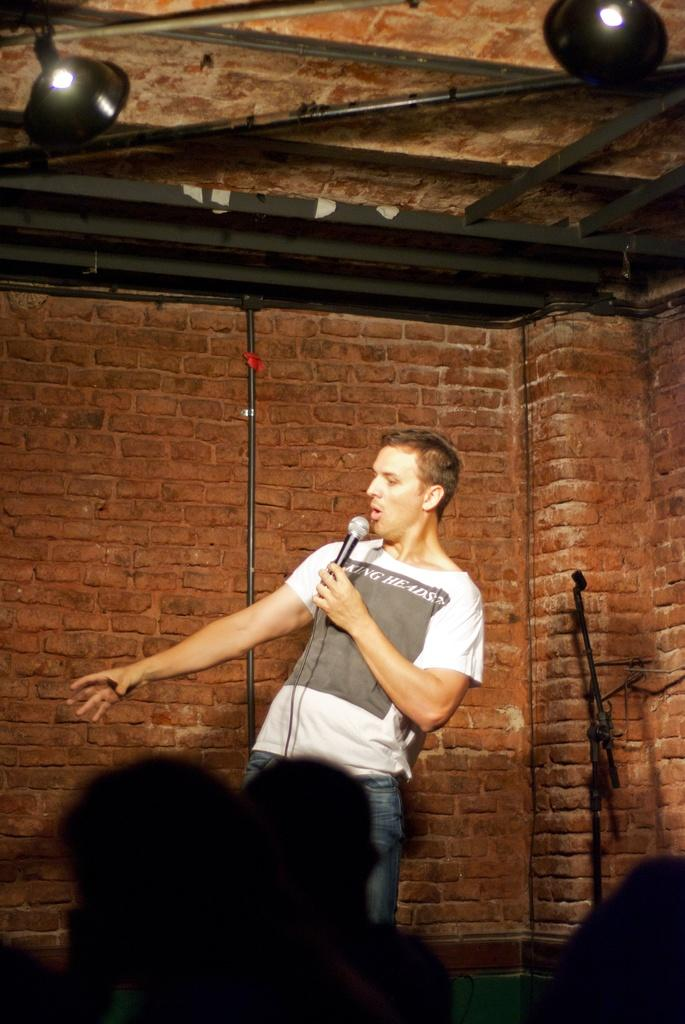What is the main subject in the center of the picture? There is a person in the center of the picture holding a mic. What can be seen in the background of the image? There is a brick wall in the background of the image. What is located on the right side of the image? There is a stand on the right side of the image. How is the foreground of the image depicted? The foreground of the image is blurred. What type of wire is being used by the police in the image? There are no police or wires present in the image. What kind of marble is visible on the ground in the image? There is no marble visible on the ground in the image. 